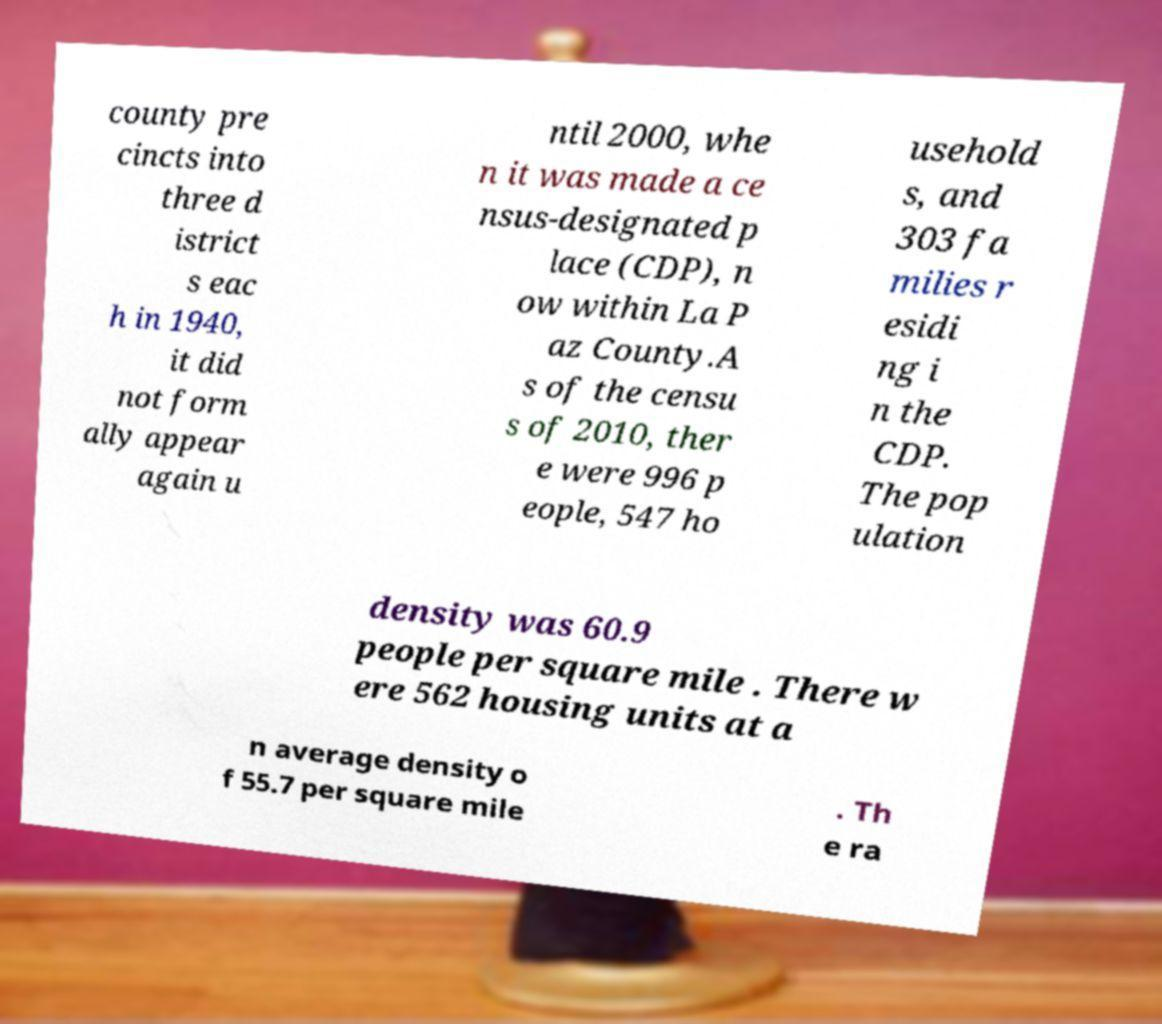For documentation purposes, I need the text within this image transcribed. Could you provide that? county pre cincts into three d istrict s eac h in 1940, it did not form ally appear again u ntil 2000, whe n it was made a ce nsus-designated p lace (CDP), n ow within La P az County.A s of the censu s of 2010, ther e were 996 p eople, 547 ho usehold s, and 303 fa milies r esidi ng i n the CDP. The pop ulation density was 60.9 people per square mile . There w ere 562 housing units at a n average density o f 55.7 per square mile . Th e ra 